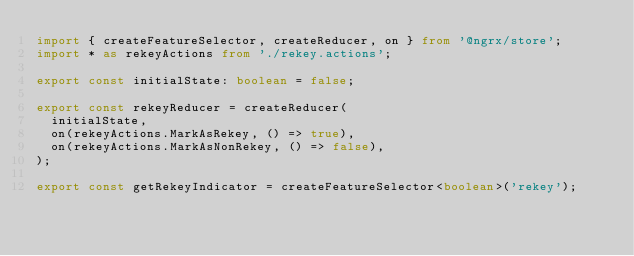Convert code to text. <code><loc_0><loc_0><loc_500><loc_500><_TypeScript_>import { createFeatureSelector, createReducer, on } from '@ngrx/store';
import * as rekeyActions from './rekey.actions';

export const initialState: boolean = false;

export const rekeyReducer = createReducer(
  initialState,
  on(rekeyActions.MarkAsRekey, () => true),
  on(rekeyActions.MarkAsNonRekey, () => false),
);

export const getRekeyIndicator = createFeatureSelector<boolean>('rekey');
</code> 